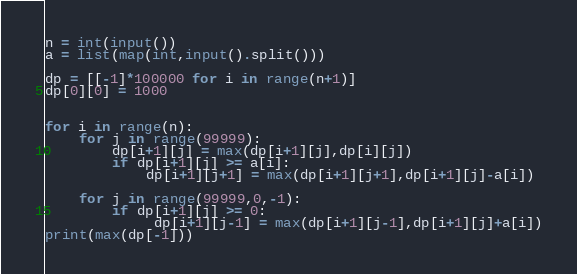<code> <loc_0><loc_0><loc_500><loc_500><_Python_>n = int(input())
a = list(map(int,input().split()))

dp = [[-1]*100000 for i in range(n+1)]
dp[0][0] = 1000


for i in range(n):
    for j in range(99999):
        dp[i+1][j] = max(dp[i+1][j],dp[i][j])
        if dp[i+1][j] >= a[i]:
            dp[i+1][j+1] = max(dp[i+1][j+1],dp[i+1][j]-a[i])
        
    for j in range(99999,0,-1):
        if dp[i+1][j] >= 0:
             dp[i+1][j-1] = max(dp[i+1][j-1],dp[i+1][j]+a[i])
print(max(dp[-1]))
</code> 